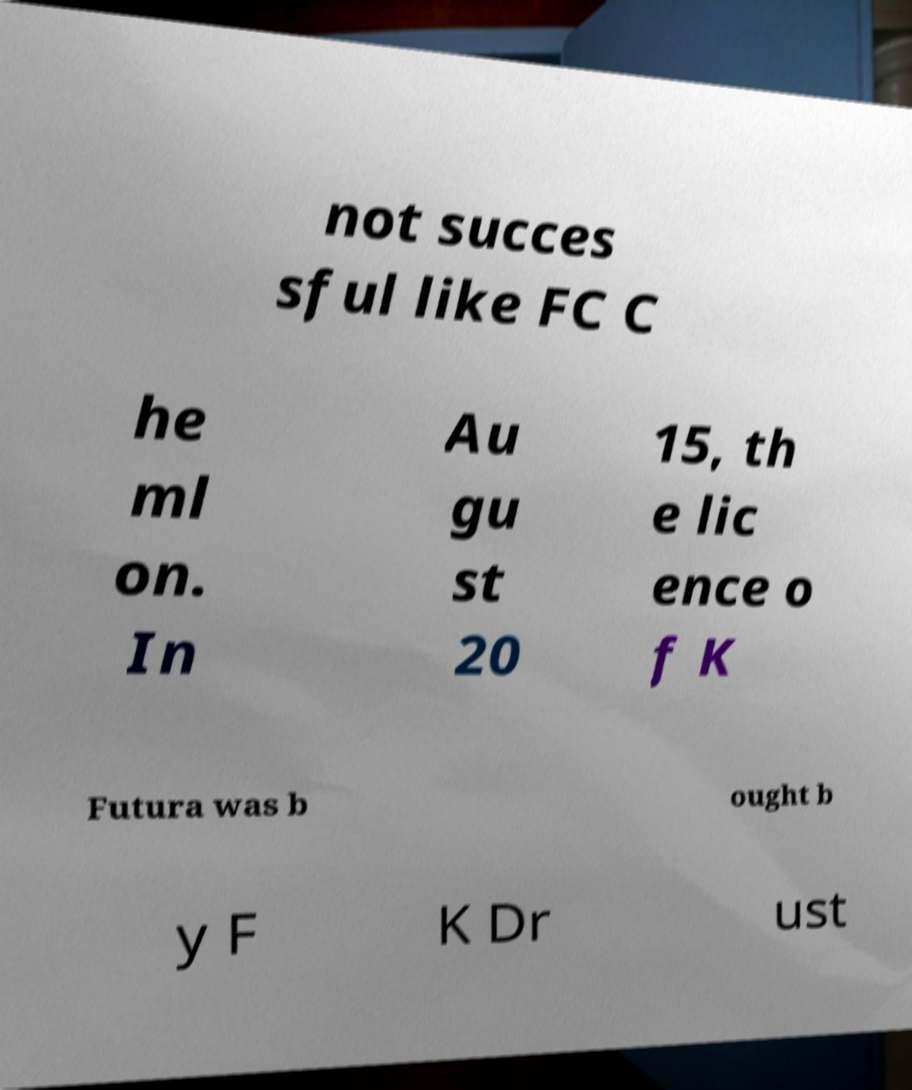Can you read and provide the text displayed in the image?This photo seems to have some interesting text. Can you extract and type it out for me? not succes sful like FC C he ml on. In Au gu st 20 15, th e lic ence o f K Futura was b ought b y F K Dr ust 